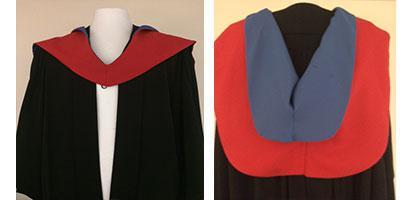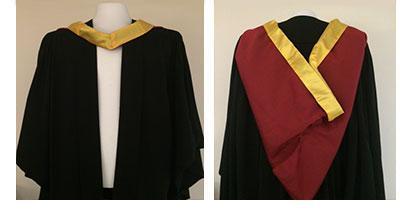The first image is the image on the left, the second image is the image on the right. Considering the images on both sides, is "A man is wearing a graduation outfit in one of the images." valid? Answer yes or no. No. 